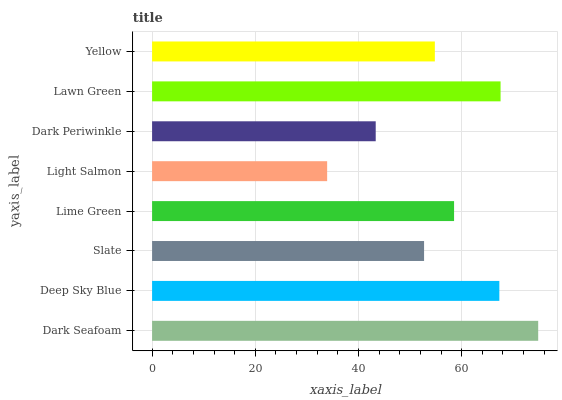Is Light Salmon the minimum?
Answer yes or no. Yes. Is Dark Seafoam the maximum?
Answer yes or no. Yes. Is Deep Sky Blue the minimum?
Answer yes or no. No. Is Deep Sky Blue the maximum?
Answer yes or no. No. Is Dark Seafoam greater than Deep Sky Blue?
Answer yes or no. Yes. Is Deep Sky Blue less than Dark Seafoam?
Answer yes or no. Yes. Is Deep Sky Blue greater than Dark Seafoam?
Answer yes or no. No. Is Dark Seafoam less than Deep Sky Blue?
Answer yes or no. No. Is Lime Green the high median?
Answer yes or no. Yes. Is Yellow the low median?
Answer yes or no. Yes. Is Lawn Green the high median?
Answer yes or no. No. Is Lawn Green the low median?
Answer yes or no. No. 